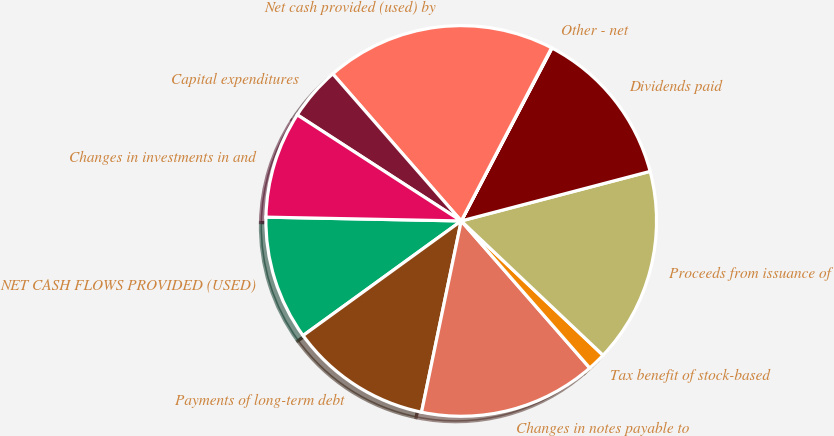<chart> <loc_0><loc_0><loc_500><loc_500><pie_chart><fcel>NET CASH FLOWS PROVIDED (USED)<fcel>Payments of long-term debt<fcel>Changes in notes payable to<fcel>Tax benefit of stock-based<fcel>Proceeds from issuance of<fcel>Dividends paid<fcel>Other - net<fcel>Net cash provided (used) by<fcel>Capital expenditures<fcel>Changes in investments in and<nl><fcel>10.29%<fcel>11.76%<fcel>14.69%<fcel>1.5%<fcel>16.15%<fcel>13.22%<fcel>0.04%<fcel>19.08%<fcel>4.43%<fcel>8.83%<nl></chart> 